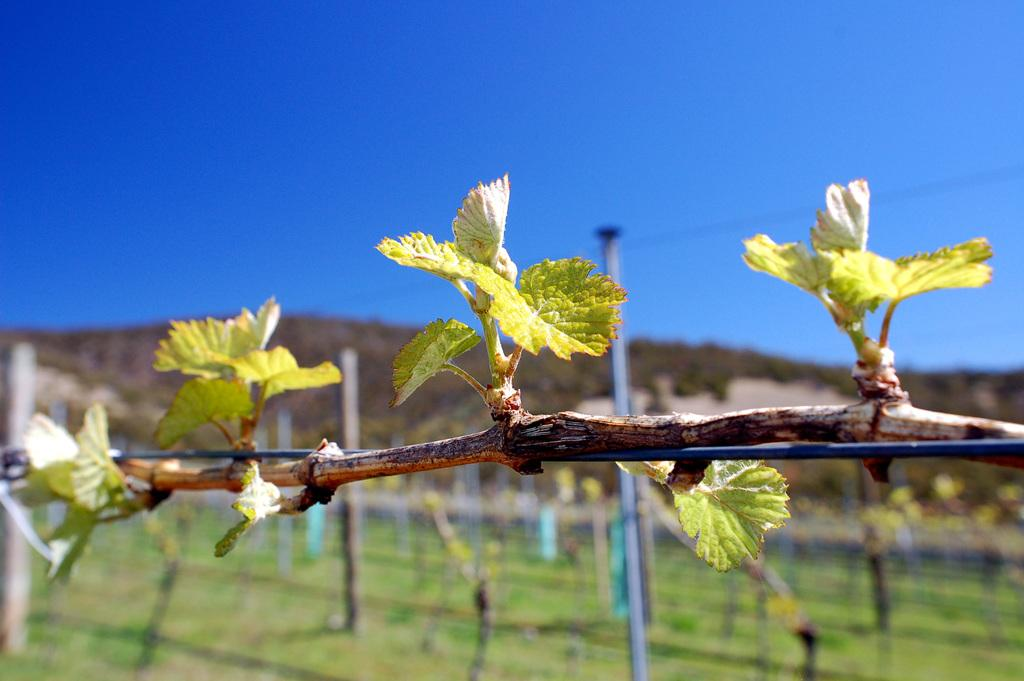What type of plant is in the image? There is a creeper in the image. How is the creeper supported in the image? The creeper is attached to cables in the image. What structures are present in the image? There are poles in the image. What natural features can be seen in the image? Hills are visible in the image. What is visible in the background of the image? The sky is visible in the image. Where is the grandmother sitting with her pump in the image? There is no grandmother or pump present in the image. What type of gun can be seen in the image? There is no gun present in the image. 